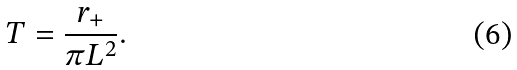<formula> <loc_0><loc_0><loc_500><loc_500>T = \frac { r _ { + } } { \pi L ^ { 2 } } .</formula> 